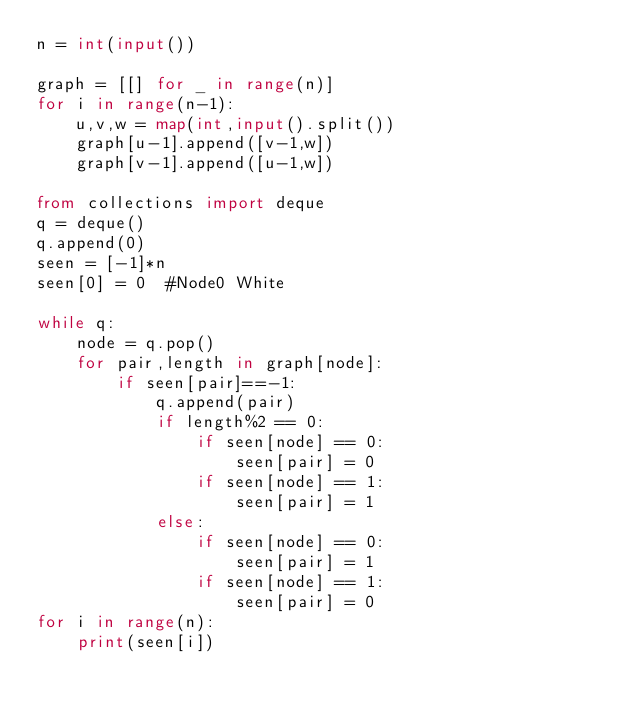<code> <loc_0><loc_0><loc_500><loc_500><_Python_>n = int(input())

graph = [[] for _ in range(n)]
for i in range(n-1):
    u,v,w = map(int,input().split())
    graph[u-1].append([v-1,w])
    graph[v-1].append([u-1,w])

from collections import deque
q = deque()
q.append(0)    
seen = [-1]*n
seen[0] = 0  #Node0 White    

while q:
    node = q.pop()
    for pair,length in graph[node]:
        if seen[pair]==-1:
            q.append(pair)
            if length%2 == 0:
                if seen[node] == 0:
                    seen[pair] = 0
                if seen[node] == 1:
                    seen[pair] = 1
            else:
                if seen[node] == 0:
                    seen[pair] = 1
                if seen[node] == 1:
                    seen[pair] = 0                         
for i in range(n):
    print(seen[i])</code> 